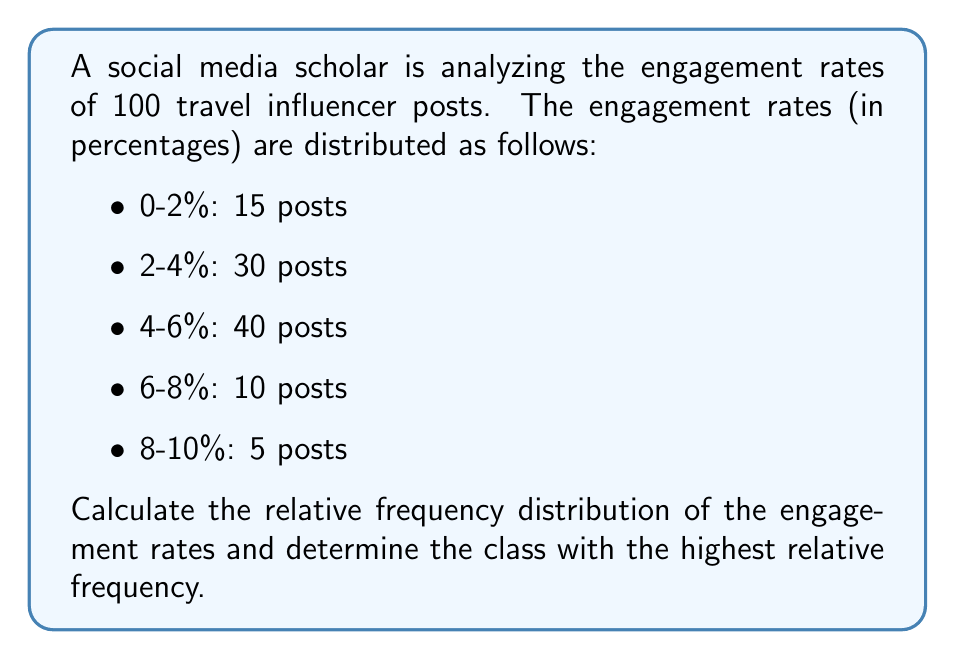Show me your answer to this math problem. To solve this problem, we need to follow these steps:

1. Calculate the total number of posts:
   $N = 15 + 30 + 40 + 10 + 5 = 100$ posts

2. Calculate the relative frequency for each class:
   Relative frequency = (Number of posts in class) / (Total number of posts)

   For 0-2%: $f_1 = \frac{15}{100} = 0.15$ or 15%
   For 2-4%: $f_2 = \frac{30}{100} = 0.30$ or 30%
   For 4-6%: $f_3 = \frac{40}{100} = 0.40$ or 40%
   For 6-8%: $f_4 = \frac{10}{100} = 0.10$ or 10%
   For 8-10%: $f_5 = \frac{5}{100} = 0.05$ or 5%

3. Verify that the sum of all relative frequencies equals 1:
   $\sum_{i=1}^5 f_i = 0.15 + 0.30 + 0.40 + 0.10 + 0.05 = 1$

4. Identify the class with the highest relative frequency:
   The highest relative frequency is 0.40 or 40%, which corresponds to the 4-6% engagement rate class.

The relative frequency distribution is:
$$
\begin{array}{|c|c|}
\hline
\text{Engagement Rate} & \text{Relative Frequency} \\
\hline
0-2\% & 0.15 \\
2-4\% & 0.30 \\
4-6\% & 0.40 \\
6-8\% & 0.10 \\
8-10\% & 0.05 \\
\hline
\end{array}
$$
Answer: Relative frequency distribution: {0.15, 0.30, 0.40, 0.10, 0.05}; Highest: 4-6% class (0.40) 